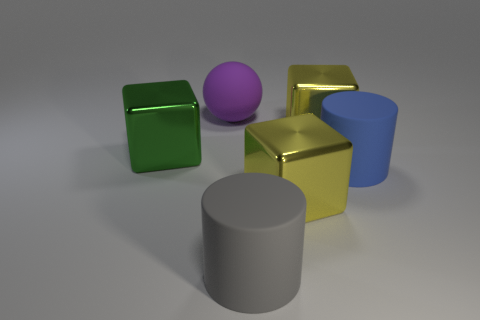The other large rubber object that is the same shape as the blue thing is what color?
Your response must be concise. Gray. Is the color of the large metallic thing that is in front of the green cube the same as the metal thing behind the green cube?
Keep it short and to the point. Yes. What number of shiny things are either large blue balls or big gray objects?
Ensure brevity in your answer.  0. How many rubber objects are to the right of the large matte cylinder that is on the left side of the large rubber cylinder that is on the right side of the big gray thing?
Make the answer very short. 1. What number of big metal objects have the same color as the large matte sphere?
Your answer should be compact. 0. There is a blue matte object in front of the ball; is its size the same as the green metal thing?
Offer a terse response. Yes. What color is the thing that is behind the green cube and on the right side of the big gray thing?
Give a very brief answer. Yellow. What number of things are either small blue cylinders or big things behind the big green metal block?
Keep it short and to the point. 2. There is a yellow cube that is behind the cube to the left of the block in front of the big blue cylinder; what is its material?
Provide a short and direct response. Metal. What number of cyan things are either large spheres or small objects?
Give a very brief answer. 0. 